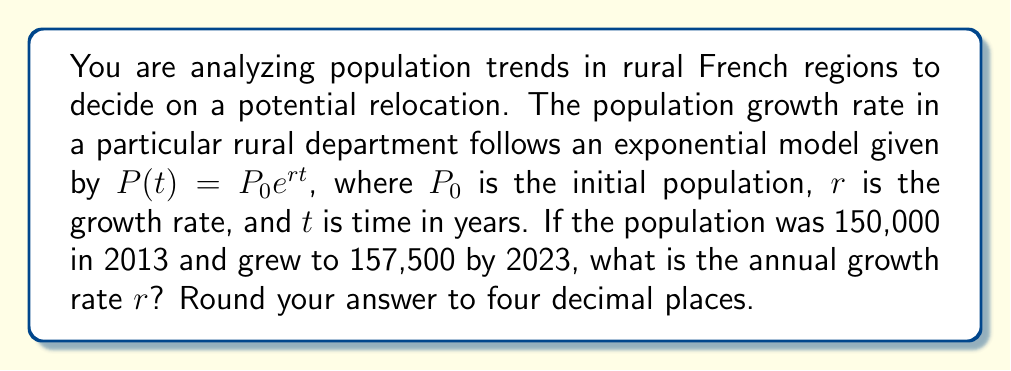Solve this math problem. To solve this problem, we'll use the exponential growth formula and the given information:

1) We know that $P(t) = P_0e^{rt}$
2) Initial population $P_0 = 150,000$
3) Final population after 10 years $P(10) = 157,500$
4) Time period $t = 10$ years

Let's substitute these values into the formula:

$$157,500 = 150,000e^{10r}$$

Now, let's solve for $r$:

1) Divide both sides by 150,000:
   $$\frac{157,500}{150,000} = e^{10r}$$

2) Simplify:
   $$1.05 = e^{10r}$$

3) Take the natural logarithm of both sides:
   $$\ln(1.05) = \ln(e^{10r})$$

4) Simplify the right side using the properties of logarithms:
   $$\ln(1.05) = 10r$$

5) Solve for $r$:
   $$r = \frac{\ln(1.05)}{10}$$

6) Calculate and round to four decimal places:
   $$r \approx 0.0049$$

This means the annual growth rate is approximately 0.0049 or 0.49% per year.
Answer: 0.0049 